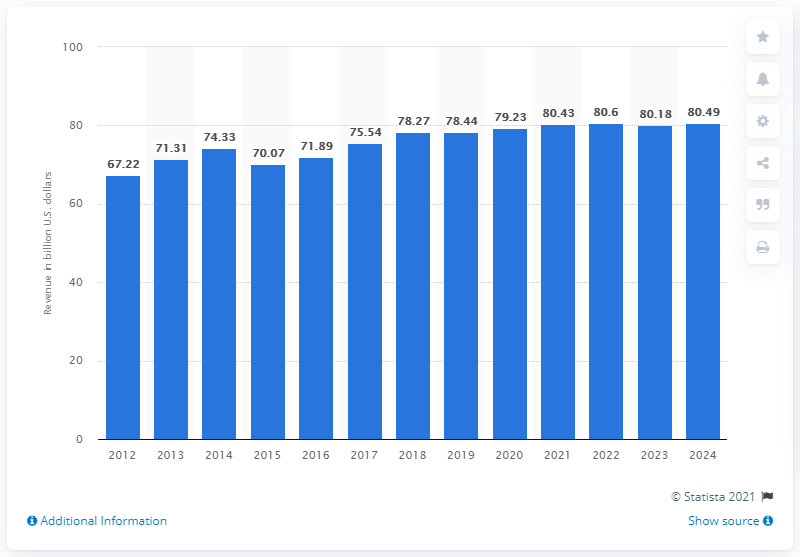Mention a couple of crucial points in this snapshot. The global revenue of Johnson & Johnson has been estimated to be approximately 78.44 billion U.S. dollars. 